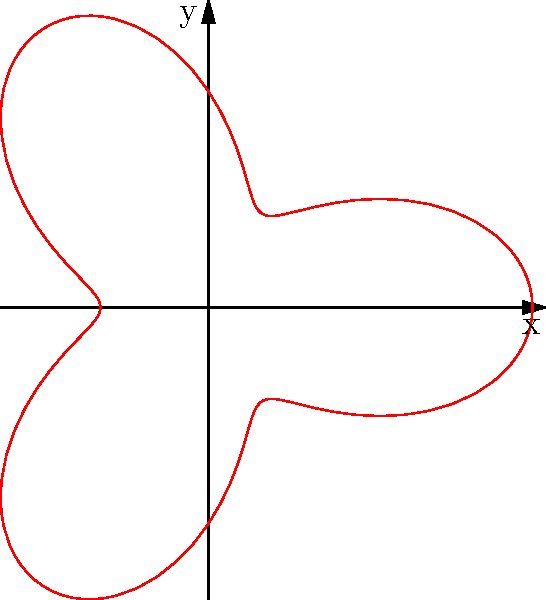During a reconnaissance mission briefing, you are presented with a polar plot representing a proposed flight path. The path is described by the equation $r = 2 + \cos(3\theta)$. What is the maximum radial distance the aircraft will reach from the origin during this flight path? To find the maximum radial distance, we need to follow these steps:

1) The equation of the path is given as $r = 2 + \cos(3\theta)$.

2) The maximum value of $r$ will occur when $\cos(3\theta)$ is at its maximum.

3) We know that the maximum value of cosine is 1, regardless of what's inside the parentheses.

4) Therefore, the maximum value of $r$ will be when $\cos(3\theta) = 1$.

5) Substituting this into our equation:

   $r_{max} = 2 + 1 = 3$

6) This means the maximum radial distance from the origin is 3 units.
Answer: 3 units 